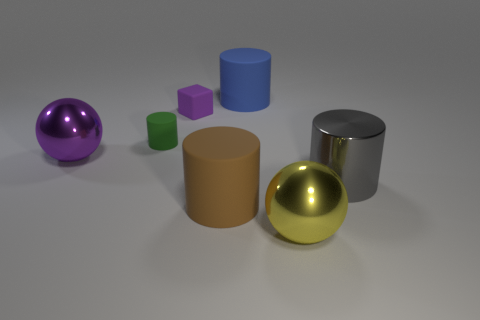What is the material of the big gray thing that is the same shape as the green thing?
Offer a terse response. Metal. Is the number of big gray objects behind the small purple object less than the number of red matte cubes?
Ensure brevity in your answer.  No. What number of big blue objects are right of the tiny cylinder?
Your response must be concise. 1. Do the rubber thing in front of the tiny green cylinder and the purple thing that is to the left of the small rubber cylinder have the same shape?
Your answer should be very brief. No. What is the shape of the object that is both behind the small green thing and in front of the large blue cylinder?
Provide a succinct answer. Cube. What size is the gray object that is made of the same material as the big yellow thing?
Your answer should be compact. Large. Is the number of shiny cylinders less than the number of big red matte objects?
Keep it short and to the point. No. What material is the large ball in front of the big shiny sphere behind the big matte cylinder that is in front of the purple sphere made of?
Offer a terse response. Metal. Do the big ball that is on the left side of the yellow thing and the large thing behind the purple metal ball have the same material?
Offer a very short reply. No. What size is the rubber object that is both behind the gray thing and in front of the small block?
Offer a terse response. Small. 